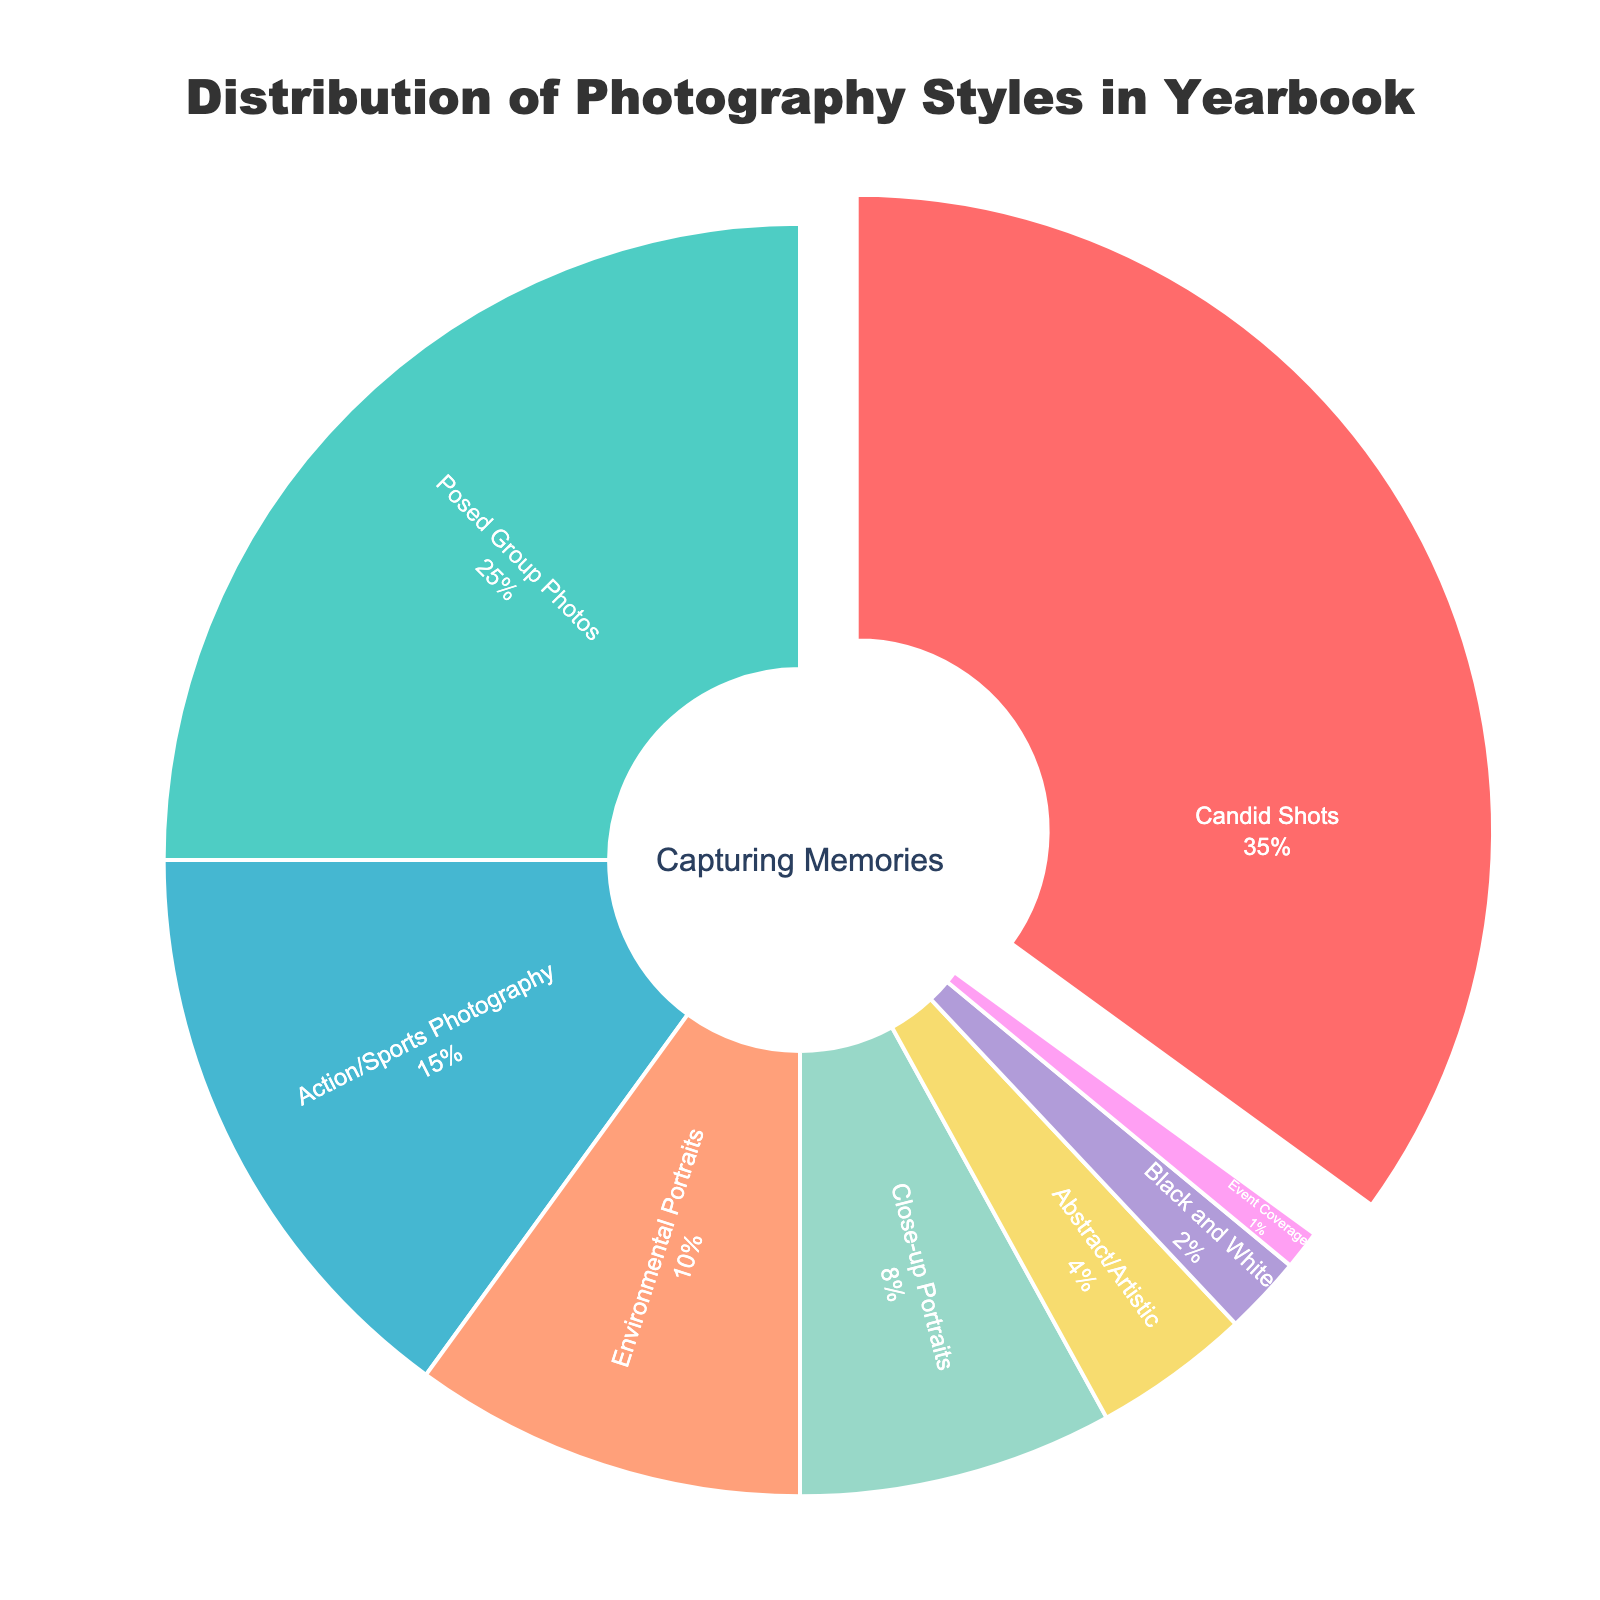What percentage of the yearbook's photography styles is dedicated to Action/Sports Photography? Look at the slice labeled "Action/Sports Photography" on the pie chart and read the percentage value displayed inside the slice.
Answer: 15% Which photography style is used the most in the yearbook? Identify the slice that is pulled out from the pie chart. This slice represents the photography style with the highest percentage.
Answer: Candid Shots What is the combined percentage of Posed Group Photos and Event Coverage? Locate the slices labeled "Posed Group Photos" and "Event Coverage." Add their percentages together: 25% + 1%.
Answer: 26% How much more percentage is spent on Candid Shots compared to Close-up Portraits? Locate the slices labeled "Candid Shots" and "Close-up Portraits," then subtract the percentage of Close-up Portraits from the percentage of Candid Shots: 35% - 8%.
Answer: 27% Which photography style occupies the smallest section of the pie chart and what percentage does it represent? Identify the smallest slice by its visual size and read its label and percentage.
Answer: Event Coverage, 1% What is the difference in percentage between Environmental Portraits and Black and White photography styles? Locate the slices labeled "Environmental Portraits" and "Black and White," then subtract the percentage of Black and White from the percentage of Environmental Portraits: 10% - 2%.
Answer: 8% What is the percentage difference between the styles with the highest and lowest representation? Identify the highest percentage (Candid Shots) and the lowest percentage (Event Coverage). Subtract these values: 35% - 1%.
Answer: 34% Which three photography styles are most represented in the yearbook and what are their combined percentages? Identify the three largest slices and sum their percentages: Candid Shots (35%), Posed Group Photos (25%), and Action/Sports Photography (15%). Add their percentages: 35% + 25% + 15%.
Answer: 75% How does the percentage of Abstract/Artistic photography compare to environmental portraits? Locate the slices for "Abstract/Artistic" and "Environmental Portraits." Compare their percentages: Abstract/Artistic (4%) is less than Environmental Portraits (10%).
Answer: Environmental Portraits is higher What is the total percentage of all photography styles excluding the top two largest ones? Exclude the percentages of Candid Shots (35%) and Posed Group Photos (25%) from the total (100%). Sum the remaining percentages: 15% + 10% + 8% + 4% + 2% + 1%.
Answer: 40% 